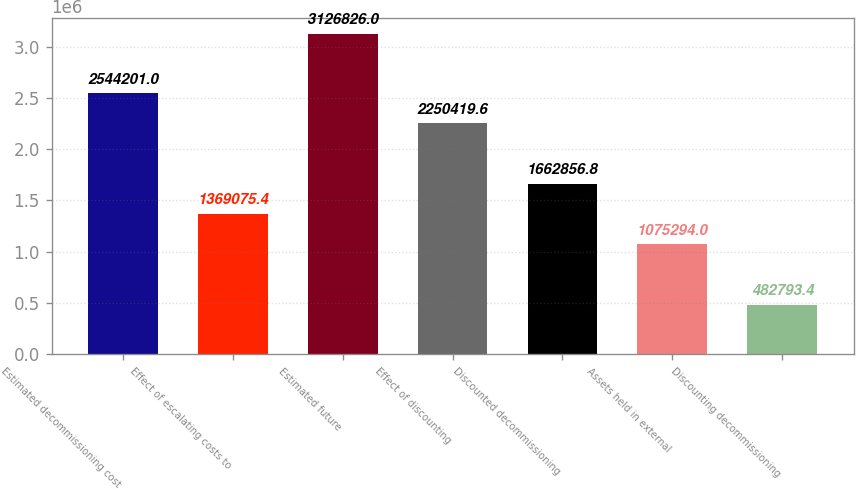Convert chart. <chart><loc_0><loc_0><loc_500><loc_500><bar_chart><fcel>Estimated decommissioning cost<fcel>Effect of escalating costs to<fcel>Estimated future<fcel>Effect of discounting<fcel>Discounted decommissioning<fcel>Assets held in external<fcel>Discounting decommissioning<nl><fcel>2.5442e+06<fcel>1.36908e+06<fcel>3.12683e+06<fcel>2.25042e+06<fcel>1.66286e+06<fcel>1.07529e+06<fcel>482793<nl></chart> 